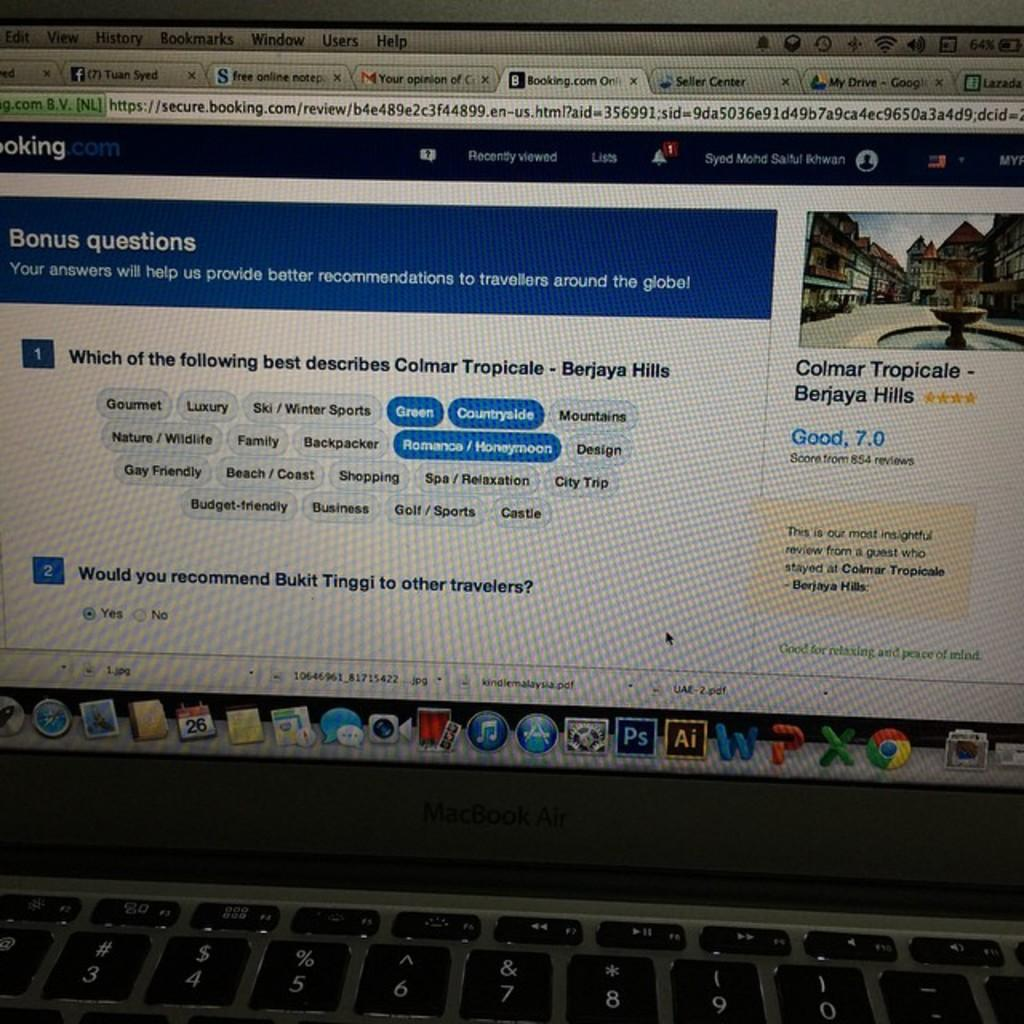Provide a one-sentence caption for the provided image. A computer screen from a MacBook Air laptop with a booking.com page displayed. 